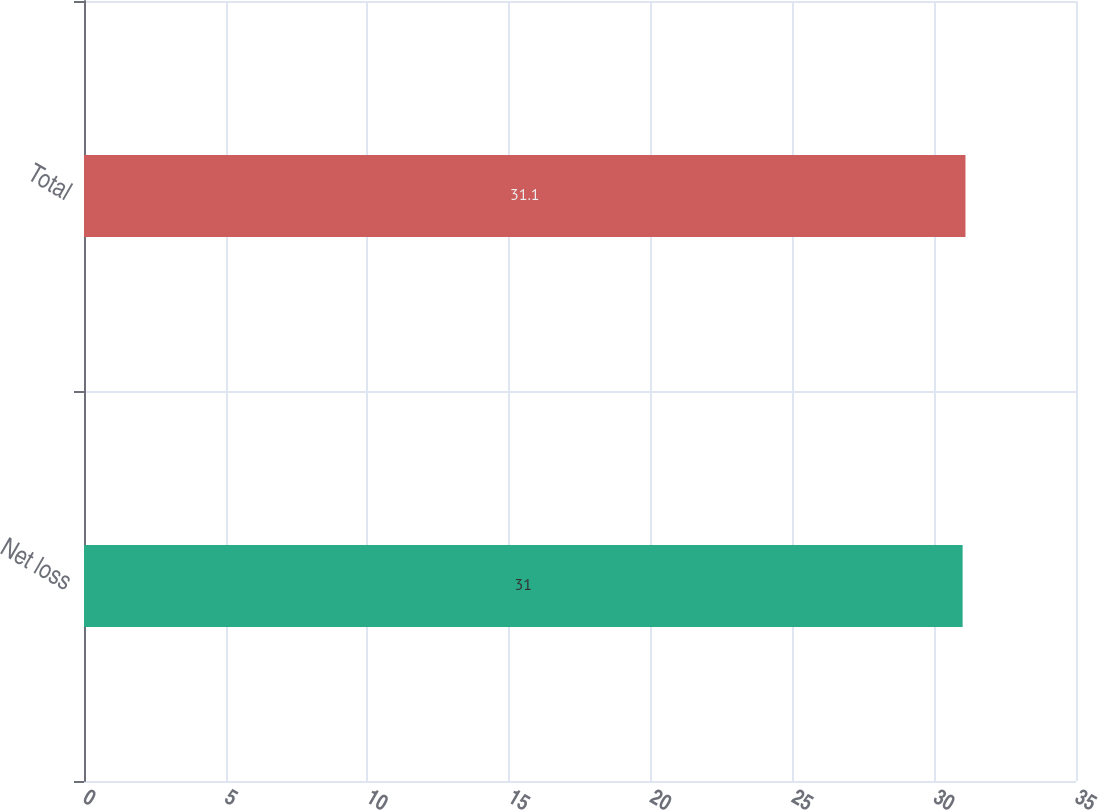<chart> <loc_0><loc_0><loc_500><loc_500><bar_chart><fcel>Net loss<fcel>Total<nl><fcel>31<fcel>31.1<nl></chart> 